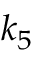<formula> <loc_0><loc_0><loc_500><loc_500>k _ { 5 }</formula> 